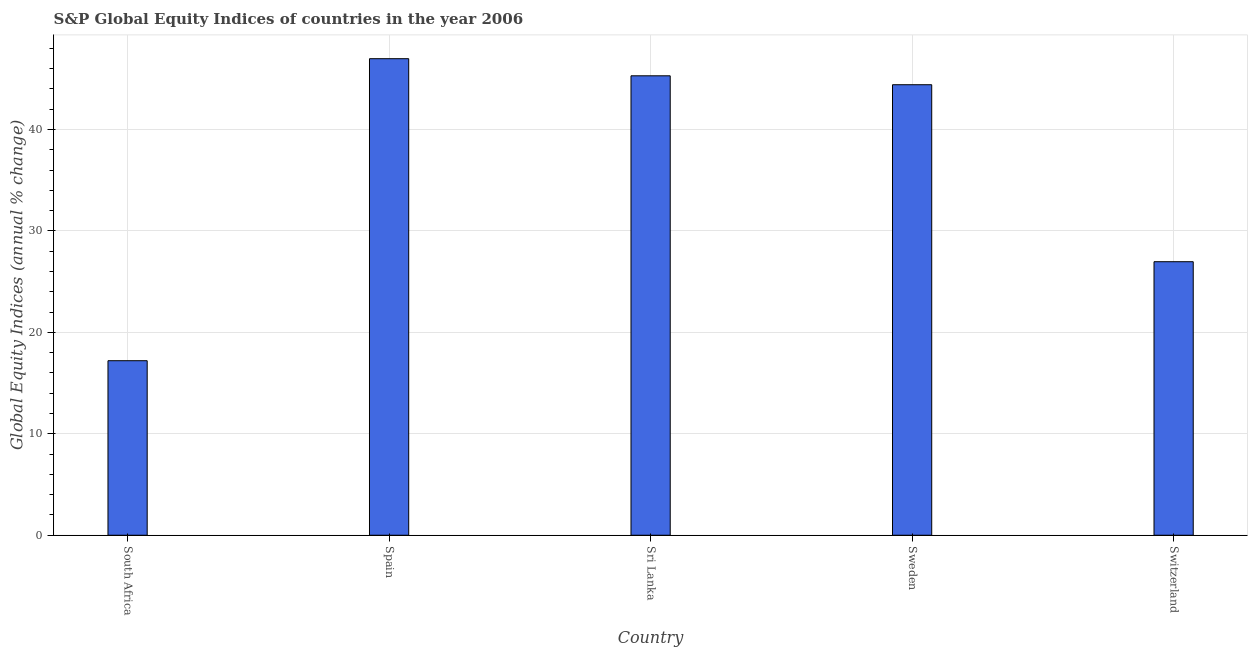Does the graph contain grids?
Provide a short and direct response. Yes. What is the title of the graph?
Keep it short and to the point. S&P Global Equity Indices of countries in the year 2006. What is the label or title of the X-axis?
Provide a short and direct response. Country. What is the label or title of the Y-axis?
Offer a very short reply. Global Equity Indices (annual % change). What is the s&p global equity indices in Sri Lanka?
Give a very brief answer. 45.29. Across all countries, what is the maximum s&p global equity indices?
Your answer should be compact. 46.98. Across all countries, what is the minimum s&p global equity indices?
Give a very brief answer. 17.2. In which country was the s&p global equity indices maximum?
Offer a terse response. Spain. In which country was the s&p global equity indices minimum?
Provide a short and direct response. South Africa. What is the sum of the s&p global equity indices?
Offer a terse response. 180.85. What is the difference between the s&p global equity indices in South Africa and Sweden?
Make the answer very short. -27.21. What is the average s&p global equity indices per country?
Provide a short and direct response. 36.17. What is the median s&p global equity indices?
Provide a short and direct response. 44.41. What is the ratio of the s&p global equity indices in Spain to that in Sweden?
Keep it short and to the point. 1.06. Is the s&p global equity indices in South Africa less than that in Switzerland?
Offer a terse response. Yes. What is the difference between the highest and the second highest s&p global equity indices?
Keep it short and to the point. 1.69. Is the sum of the s&p global equity indices in Sri Lanka and Sweden greater than the maximum s&p global equity indices across all countries?
Provide a short and direct response. Yes. What is the difference between the highest and the lowest s&p global equity indices?
Keep it short and to the point. 29.77. In how many countries, is the s&p global equity indices greater than the average s&p global equity indices taken over all countries?
Provide a short and direct response. 3. Are all the bars in the graph horizontal?
Provide a succinct answer. No. What is the Global Equity Indices (annual % change) of South Africa?
Offer a very short reply. 17.2. What is the Global Equity Indices (annual % change) of Spain?
Your response must be concise. 46.98. What is the Global Equity Indices (annual % change) of Sri Lanka?
Ensure brevity in your answer.  45.29. What is the Global Equity Indices (annual % change) in Sweden?
Give a very brief answer. 44.41. What is the Global Equity Indices (annual % change) of Switzerland?
Provide a short and direct response. 26.96. What is the difference between the Global Equity Indices (annual % change) in South Africa and Spain?
Provide a short and direct response. -29.77. What is the difference between the Global Equity Indices (annual % change) in South Africa and Sri Lanka?
Give a very brief answer. -28.09. What is the difference between the Global Equity Indices (annual % change) in South Africa and Sweden?
Keep it short and to the point. -27.21. What is the difference between the Global Equity Indices (annual % change) in South Africa and Switzerland?
Keep it short and to the point. -9.76. What is the difference between the Global Equity Indices (annual % change) in Spain and Sri Lanka?
Keep it short and to the point. 1.69. What is the difference between the Global Equity Indices (annual % change) in Spain and Sweden?
Your answer should be very brief. 2.56. What is the difference between the Global Equity Indices (annual % change) in Spain and Switzerland?
Keep it short and to the point. 20.01. What is the difference between the Global Equity Indices (annual % change) in Sri Lanka and Sweden?
Ensure brevity in your answer.  0.88. What is the difference between the Global Equity Indices (annual % change) in Sri Lanka and Switzerland?
Your answer should be compact. 18.33. What is the difference between the Global Equity Indices (annual % change) in Sweden and Switzerland?
Your response must be concise. 17.45. What is the ratio of the Global Equity Indices (annual % change) in South Africa to that in Spain?
Give a very brief answer. 0.37. What is the ratio of the Global Equity Indices (annual % change) in South Africa to that in Sri Lanka?
Provide a succinct answer. 0.38. What is the ratio of the Global Equity Indices (annual % change) in South Africa to that in Sweden?
Keep it short and to the point. 0.39. What is the ratio of the Global Equity Indices (annual % change) in South Africa to that in Switzerland?
Your answer should be compact. 0.64. What is the ratio of the Global Equity Indices (annual % change) in Spain to that in Sweden?
Your answer should be very brief. 1.06. What is the ratio of the Global Equity Indices (annual % change) in Spain to that in Switzerland?
Offer a very short reply. 1.74. What is the ratio of the Global Equity Indices (annual % change) in Sri Lanka to that in Sweden?
Offer a very short reply. 1.02. What is the ratio of the Global Equity Indices (annual % change) in Sri Lanka to that in Switzerland?
Provide a short and direct response. 1.68. What is the ratio of the Global Equity Indices (annual % change) in Sweden to that in Switzerland?
Keep it short and to the point. 1.65. 